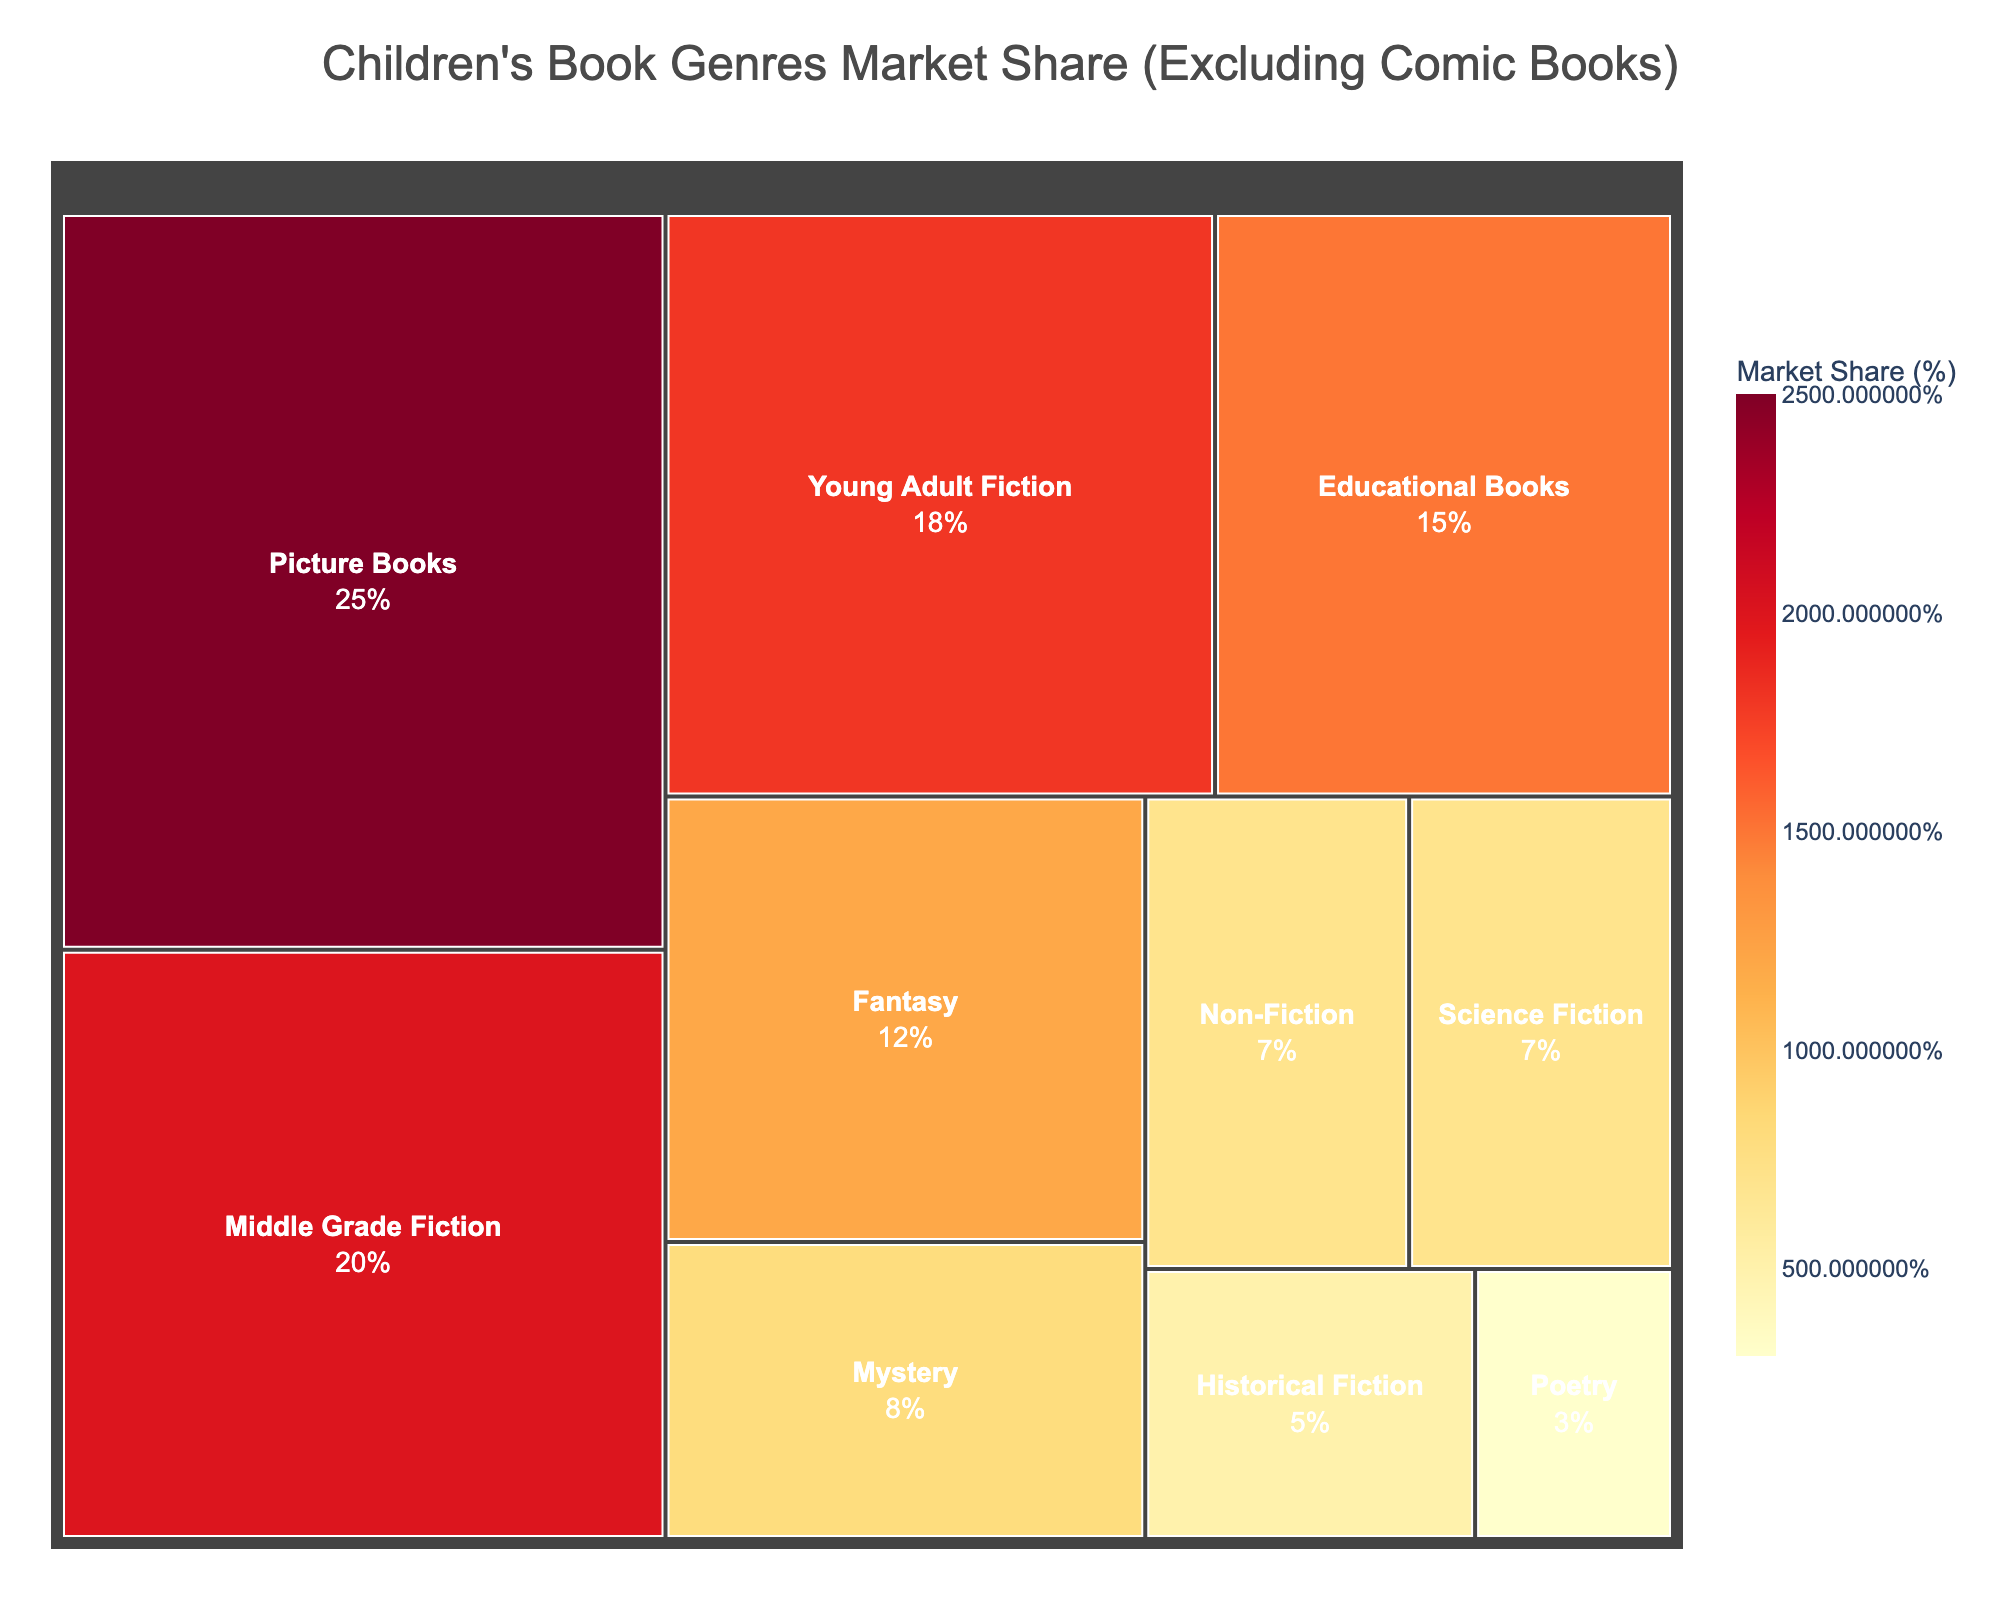What's the title of the figure? The title of the figure is typically displayed prominently at the top. In this case, it is specified in the code as "Children's Book Genres Market Share (Excluding Comic Books)".
Answer: Children's Book Genres Market Share (Excluding Comic Books) Which genre has the largest market share? The largest section in the treemap represents the genre with the largest market share. According to the provided data, Picture Books have a 25% market share, which is the highest.
Answer: Picture Books What is the market share of Middle Grade Fiction? The market share of each genre is explicitly stated within each section of the treemap. Middle Grade Fiction has a market share of 20%, as specified in the data.
Answer: 20% What is the combined market share of Fantasy and Science Fiction? To find the combined market share, you add the market shares of Fantasy (12%) and Science Fiction (7%). 12% + 7% = 19%.
Answer: 19% Which genre has a smaller market share, Mystery or Historical Fiction? By comparing the sizes and values of the sections, Mystery has a market share of 8%, whereas Historical Fiction has 5%. Therefore, Historical Fiction has a smaller market share.
Answer: Historical Fiction What is the difference in market share between Educational Books and Young Adult Fiction? The market share of Educational Books is 15%, and the market share of Young Adult Fiction is 18%. The difference is: 18% - 15% = 3%.
Answer: 3% Which genres make up more than 10% of the market share individually? The treemap and the data reveal the market shares. Picture Books (25%), Middle Grade Fiction (20%), Young Adult Fiction (18%), and Fantasy (12%) all individually make up more than 10% of the market share.
Answer: Picture Books, Middle Grade Fiction, Young Adult Fiction, Fantasy Rank the genres in descending order of their market share. By examining the values associated with each genre, we order them from highest to lowest: Picture Books (25%), Middle Grade Fiction (20%), Young Adult Fiction (18%), Educational Books (15%), Fantasy (12%), Mystery (8%), Non-Fiction (7%), Science Fiction (7%), Historical Fiction (5%), Poetry (3%).
Answer: Picture Books, Middle Grade Fiction, Young Adult Fiction, Educational Books, Fantasy, Mystery, Non-Fiction, Science Fiction, Historical Fiction, Poetry 